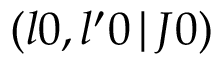Convert formula to latex. <formula><loc_0><loc_0><loc_500><loc_500>\left ( l 0 , l ^ { \prime } 0 \, | \, J 0 \right )</formula> 